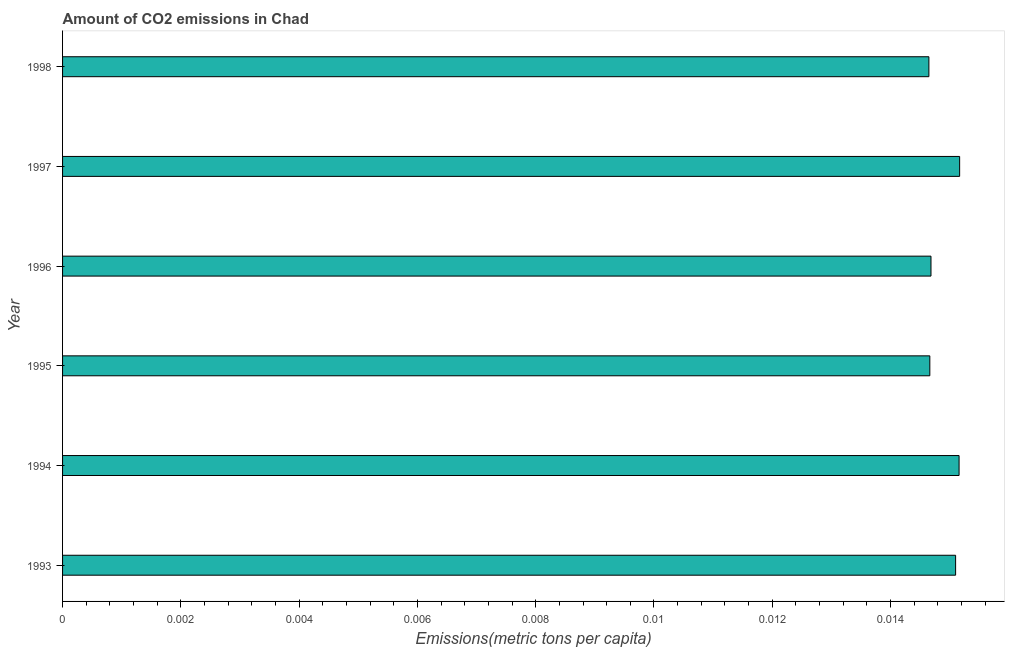Does the graph contain any zero values?
Provide a succinct answer. No. Does the graph contain grids?
Your answer should be very brief. No. What is the title of the graph?
Your response must be concise. Amount of CO2 emissions in Chad. What is the label or title of the X-axis?
Keep it short and to the point. Emissions(metric tons per capita). What is the amount of co2 emissions in 1995?
Make the answer very short. 0.01. Across all years, what is the maximum amount of co2 emissions?
Provide a short and direct response. 0.02. Across all years, what is the minimum amount of co2 emissions?
Your answer should be very brief. 0.01. In which year was the amount of co2 emissions maximum?
Offer a terse response. 1997. In which year was the amount of co2 emissions minimum?
Give a very brief answer. 1998. What is the sum of the amount of co2 emissions?
Offer a terse response. 0.09. What is the average amount of co2 emissions per year?
Your response must be concise. 0.01. What is the median amount of co2 emissions?
Offer a terse response. 0.01. In how many years, is the amount of co2 emissions greater than 0.0008 metric tons per capita?
Provide a short and direct response. 6. What is the difference between the highest and the second highest amount of co2 emissions?
Ensure brevity in your answer.  0. Is the sum of the amount of co2 emissions in 1995 and 1997 greater than the maximum amount of co2 emissions across all years?
Your answer should be compact. Yes. What is the difference between the highest and the lowest amount of co2 emissions?
Ensure brevity in your answer.  0. In how many years, is the amount of co2 emissions greater than the average amount of co2 emissions taken over all years?
Make the answer very short. 3. What is the difference between two consecutive major ticks on the X-axis?
Your answer should be very brief. 0. Are the values on the major ticks of X-axis written in scientific E-notation?
Your answer should be compact. No. What is the Emissions(metric tons per capita) of 1993?
Make the answer very short. 0.02. What is the Emissions(metric tons per capita) in 1994?
Offer a very short reply. 0.02. What is the Emissions(metric tons per capita) of 1995?
Your answer should be very brief. 0.01. What is the Emissions(metric tons per capita) of 1996?
Give a very brief answer. 0.01. What is the Emissions(metric tons per capita) in 1997?
Your answer should be compact. 0.02. What is the Emissions(metric tons per capita) in 1998?
Make the answer very short. 0.01. What is the difference between the Emissions(metric tons per capita) in 1993 and 1994?
Your response must be concise. -6e-5. What is the difference between the Emissions(metric tons per capita) in 1993 and 1995?
Provide a succinct answer. 0. What is the difference between the Emissions(metric tons per capita) in 1993 and 1996?
Ensure brevity in your answer.  0. What is the difference between the Emissions(metric tons per capita) in 1993 and 1997?
Provide a succinct answer. -7e-5. What is the difference between the Emissions(metric tons per capita) in 1993 and 1998?
Provide a succinct answer. 0. What is the difference between the Emissions(metric tons per capita) in 1994 and 1995?
Offer a terse response. 0. What is the difference between the Emissions(metric tons per capita) in 1994 and 1996?
Provide a short and direct response. 0. What is the difference between the Emissions(metric tons per capita) in 1994 and 1997?
Your answer should be compact. -1e-5. What is the difference between the Emissions(metric tons per capita) in 1994 and 1998?
Provide a short and direct response. 0. What is the difference between the Emissions(metric tons per capita) in 1995 and 1996?
Give a very brief answer. -2e-5. What is the difference between the Emissions(metric tons per capita) in 1995 and 1997?
Make the answer very short. -0. What is the difference between the Emissions(metric tons per capita) in 1995 and 1998?
Make the answer very short. 2e-5. What is the difference between the Emissions(metric tons per capita) in 1996 and 1997?
Make the answer very short. -0. What is the difference between the Emissions(metric tons per capita) in 1996 and 1998?
Offer a terse response. 4e-5. What is the difference between the Emissions(metric tons per capita) in 1997 and 1998?
Your response must be concise. 0. What is the ratio of the Emissions(metric tons per capita) in 1993 to that in 1994?
Provide a succinct answer. 1. What is the ratio of the Emissions(metric tons per capita) in 1993 to that in 1995?
Offer a terse response. 1.03. What is the ratio of the Emissions(metric tons per capita) in 1993 to that in 1996?
Your answer should be very brief. 1.03. What is the ratio of the Emissions(metric tons per capita) in 1993 to that in 1998?
Ensure brevity in your answer.  1.03. What is the ratio of the Emissions(metric tons per capita) in 1994 to that in 1995?
Provide a short and direct response. 1.03. What is the ratio of the Emissions(metric tons per capita) in 1994 to that in 1996?
Provide a short and direct response. 1.03. What is the ratio of the Emissions(metric tons per capita) in 1994 to that in 1998?
Your answer should be very brief. 1.03. What is the ratio of the Emissions(metric tons per capita) in 1995 to that in 1996?
Your response must be concise. 1. What is the ratio of the Emissions(metric tons per capita) in 1995 to that in 1998?
Your answer should be compact. 1. What is the ratio of the Emissions(metric tons per capita) in 1996 to that in 1997?
Offer a terse response. 0.97. What is the ratio of the Emissions(metric tons per capita) in 1996 to that in 1998?
Provide a succinct answer. 1. What is the ratio of the Emissions(metric tons per capita) in 1997 to that in 1998?
Your response must be concise. 1.03. 